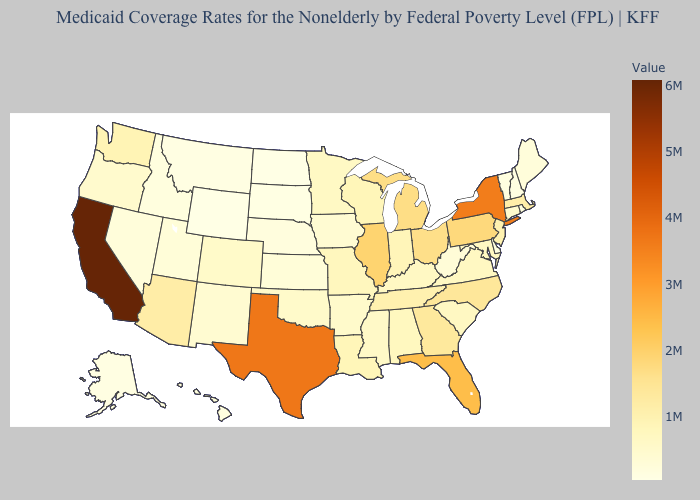Among the states that border California , does Arizona have the lowest value?
Concise answer only. No. Does North Dakota have the lowest value in the USA?
Give a very brief answer. Yes. Does the map have missing data?
Short answer required. No. Does Colorado have a lower value than California?
Be succinct. Yes. Does Louisiana have the highest value in the USA?
Keep it brief. No. Among the states that border Kansas , which have the highest value?
Answer briefly. Missouri. Among the states that border New Hampshire , does Vermont have the highest value?
Keep it brief. No. 